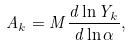Convert formula to latex. <formula><loc_0><loc_0><loc_500><loc_500>A _ { k } = M \frac { d \ln Y _ { k } } { d \ln \alpha } ,</formula> 